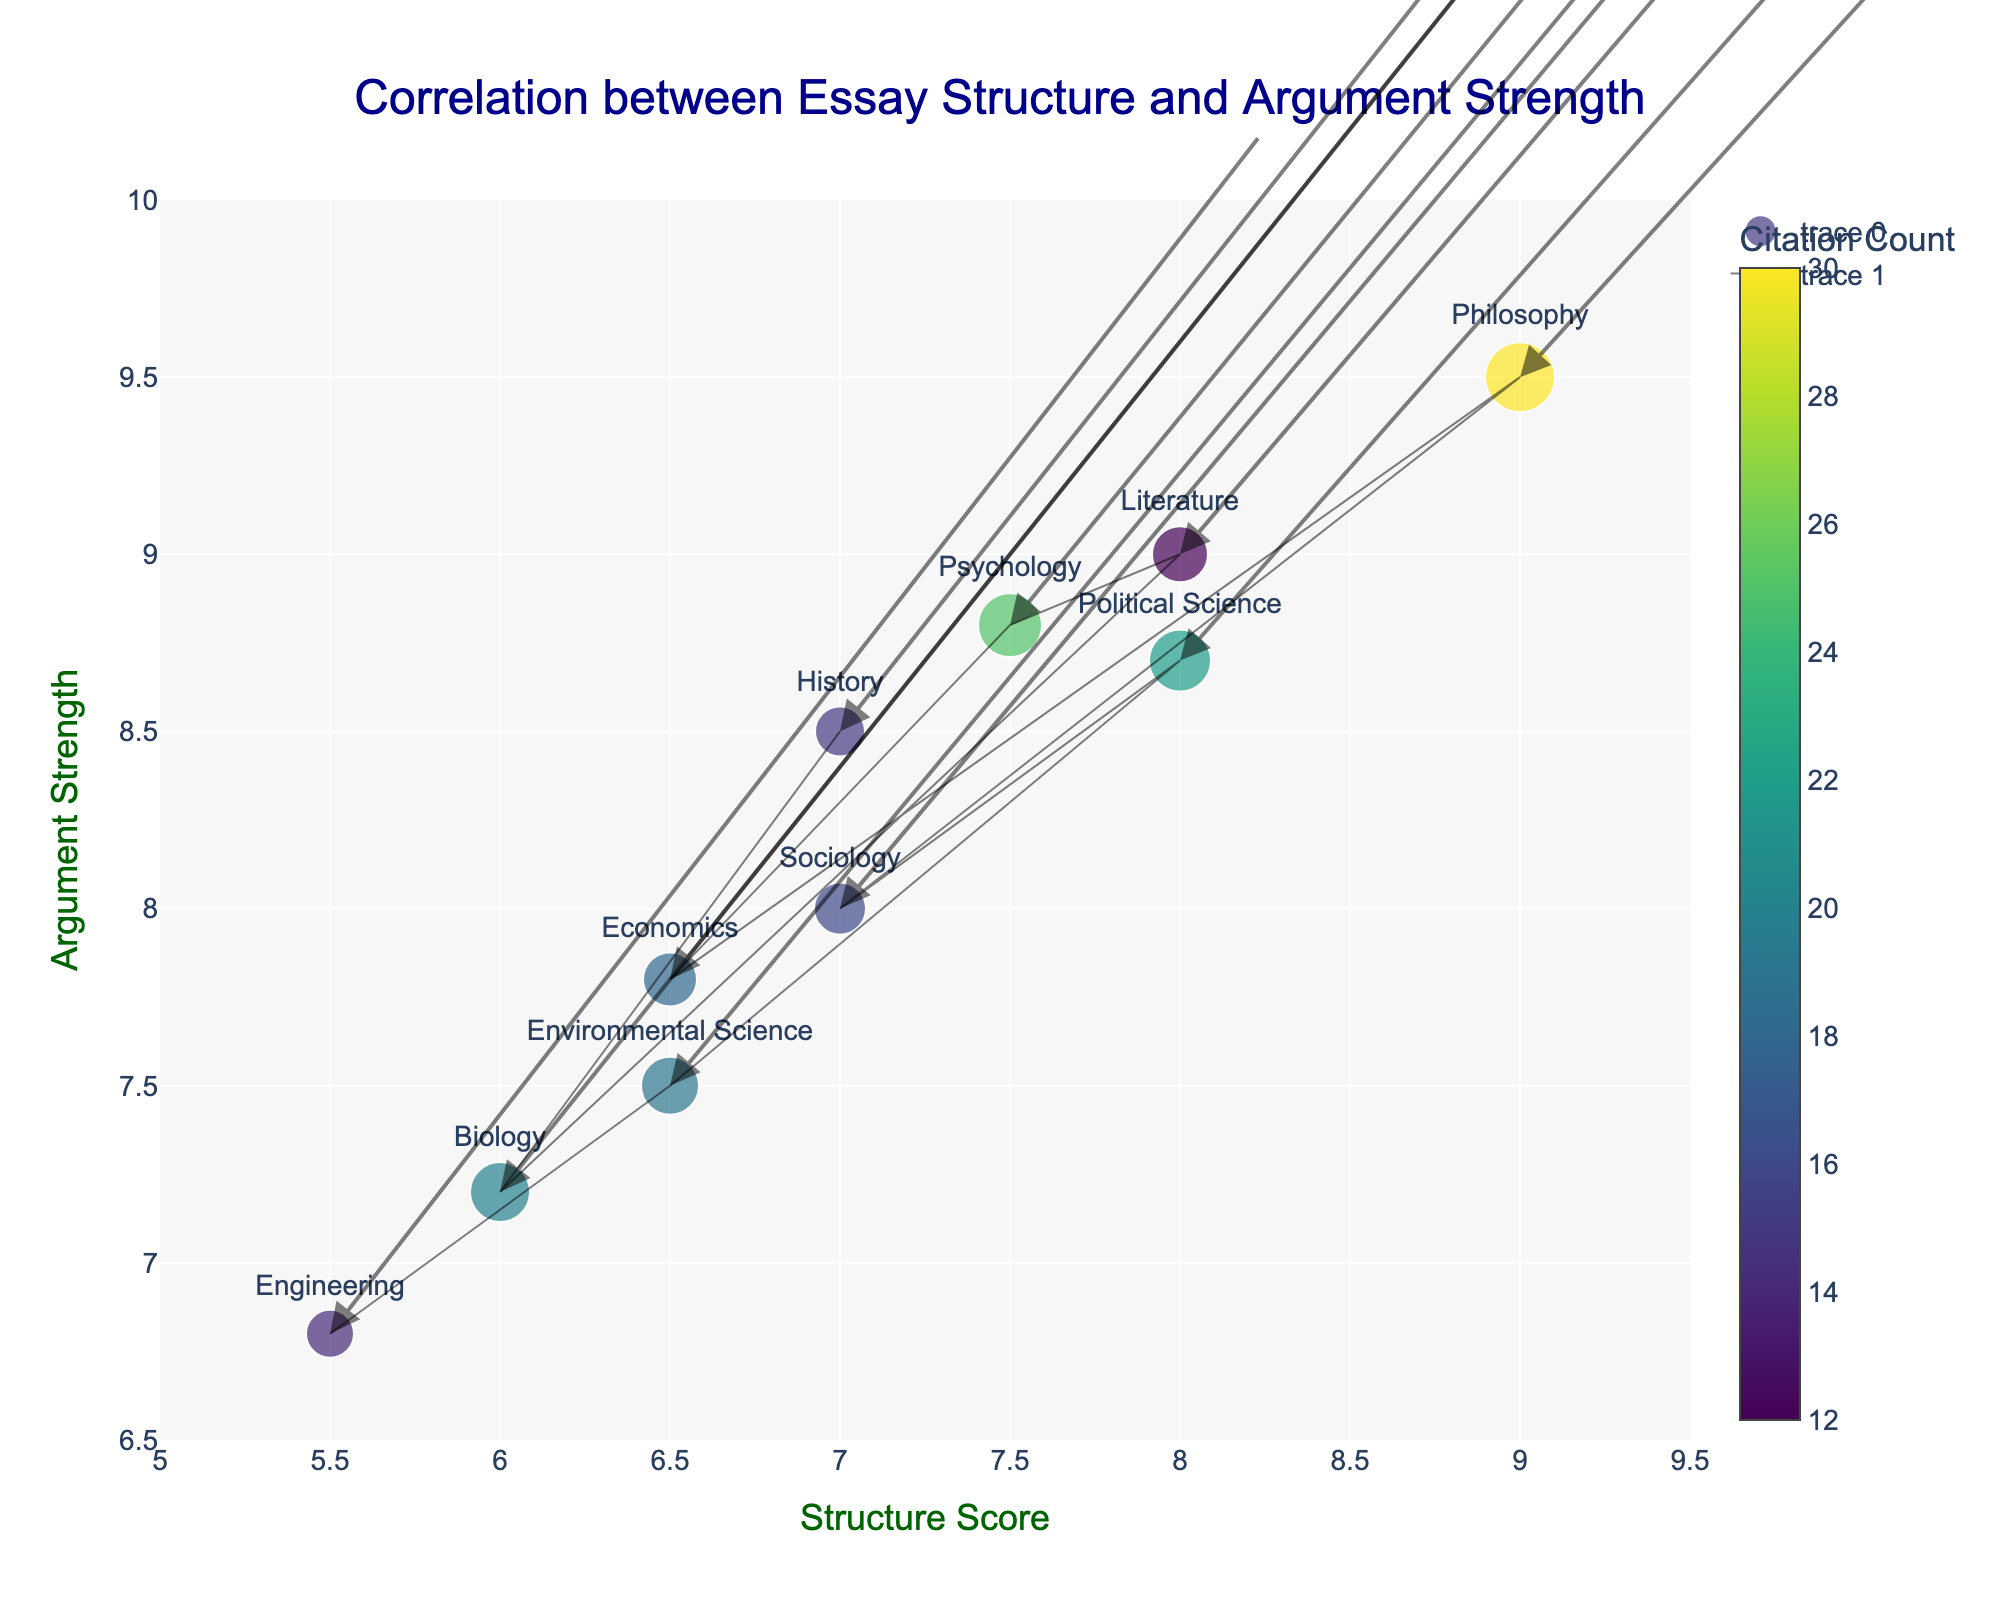What is the title of the plot? The title is typically found at the top of the plot. In this figure, the title is written in a larger, prominent font and placed centrally. It summarizes the main focus of the visualization.
Answer: Correlation between Essay Structure and Argument Strength How many disciplines are represented in the plot? You can count the number of unique text labels on the figure, as each label represents a different academic discipline.
Answer: 10 Which discipline has the highest argument strength? Look for the label on the y-axis with the highest value on the argument strength axis. The corresponding text label will identify the discipline.
Answer: Philosophy Which discipline has the lowest structure score? Identify the text label with the lowest value on the x-axis, which represents the structure score.
Answer: Engineering Which discipline has the most citations? Observe the colors used in the markers, as they correspond to the citation count. The color bar indicates that the darkest shade represents the highest citation count.
Answer: Philosophy What is the dispersal (magnitude) difference between History and Philosophy? Calculate the magnitude for each discipline using the formula √(structure_score² + argument_strength²). For History (7, 8.5) it's √(7² + 8.5²) ~ 11.26. For Philosophy (9, 9.5), it's √(9² + 9.5²) ~ 13.07. The difference is 13.07 - 11.26 ≈ 1.81.
Answer: 1.81 What is the average length of essays across all disciplines? Add the essay lengths for all disciplines and divide by the number of disciplines: (2500 + 3000 + 2800 + 3200 + 2700 + 3500 + 2600 + 3100 + 2900 + 2400) / 10 = 28700 / 10 = 2870.
Answer: 2870 How does Sociology compare to Political Science in terms of argument strength and structure score? Compare the structure score and argument strength of Sociology and Political Science by looking at their respective positions on the x-axis (structure score) and y-axis (argument strength). Sociology (7, 8.0), Political Science (8, 8.7): Political Science has higher scores in both metrics.
Answer: Political Science has higher scores Which disciplines have argument strengths greater than 8.5 but different structures scores? Identify the disciplines with argument strengths greater than 8.5 using the y-axis, then check their structure scores to ensure they differ. These disciplines are History, Psychology, Political Science, and Philosophy, with scores (7, 7.5, 8, 9) respectively.
Answer: History, Psychology, Political Science, Philosophy 